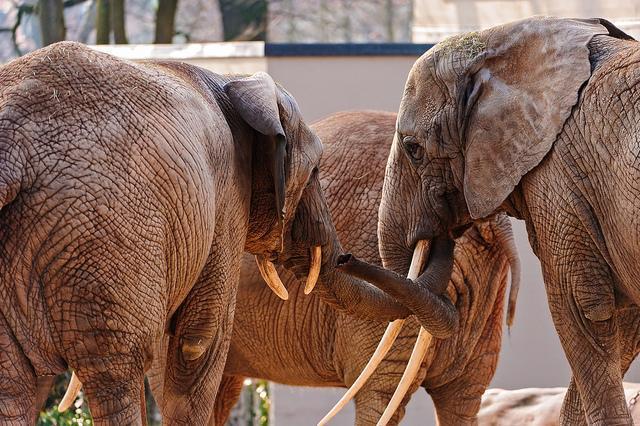How many elephants are in the photo?
Give a very brief answer. 3. How many forks are in the picture?
Give a very brief answer. 0. 